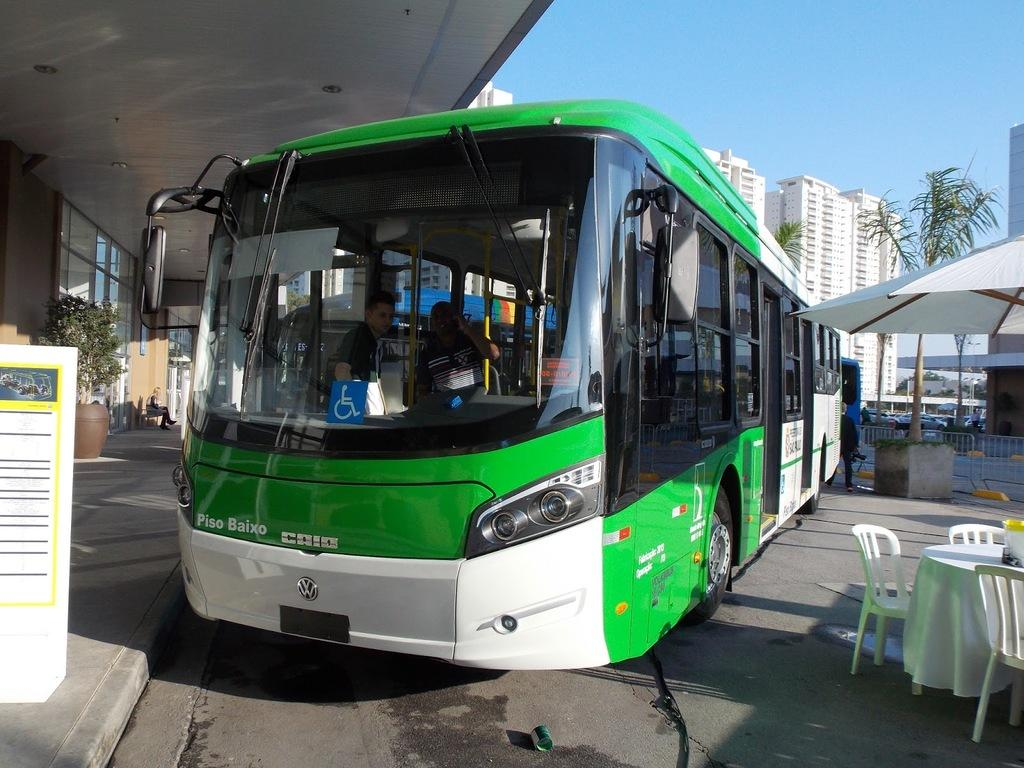What is the main subject of the image? There is a bus in the image. What other objects can be seen in the image? There is a table and a chair in the image. What is visible in the background of the image? There is a building visible in the background of the image. What type of polish is being applied to the bus in the image? There is no indication in the image that any polish is being applied to the bus. 